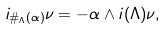Convert formula to latex. <formula><loc_0><loc_0><loc_500><loc_500>i _ { \# _ { \Lambda } ( \alpha ) } \nu = - \alpha \wedge i ( \Lambda ) \nu ,</formula> 